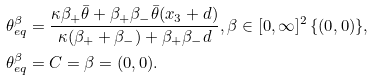Convert formula to latex. <formula><loc_0><loc_0><loc_500><loc_500>\theta _ { e q } ^ { \beta } & = \frac { \kappa \beta _ { + } \bar { \theta } + \beta _ { + } \beta _ { - } \bar { \theta } ( x _ { 3 } + d ) } { \kappa ( \beta _ { + } + \beta _ { - } ) + \beta _ { + } \beta _ { - } d } , \beta \in [ 0 , \infty ] ^ { 2 } \ \{ ( 0 , 0 ) \} , \\ \theta _ { e q } ^ { \beta } & = C = \beta = ( 0 , 0 ) .</formula> 